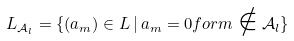<formula> <loc_0><loc_0><loc_500><loc_500>L _ { \mathcal { A } _ { l } } = \{ ( a _ { m } ) \in L \, | \, a _ { m } = 0 f o r m \notin \mathcal { A } _ { l } \}</formula> 